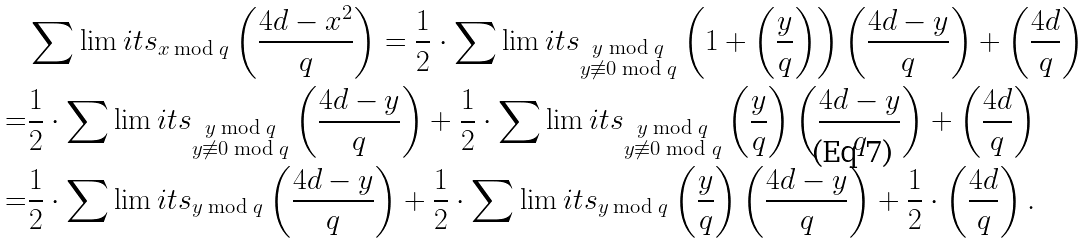Convert formula to latex. <formula><loc_0><loc_0><loc_500><loc_500>& \sum \lim i t s _ { x \bmod { q } } \left ( \frac { 4 d - x ^ { 2 } } { q } \right ) = \frac { 1 } { 2 } \cdot \sum \lim i t s _ { \substack { y \bmod { q } \\ y \not \equiv 0 \bmod { q } } } \left ( 1 + \left ( \frac { y } { q } \right ) \right ) \left ( \frac { 4 d - y } { q } \right ) + \left ( \frac { 4 d } { q } \right ) \\ = & \frac { 1 } { 2 } \cdot \sum \lim i t s _ { \substack { y \bmod { q } \\ y \not \equiv 0 \bmod { q } } } \left ( \frac { 4 d - y } { q } \right ) + \frac { 1 } { 2 } \cdot \sum \lim i t s _ { \substack { y \bmod { q } \\ y \not \equiv 0 \bmod { q } } } \left ( \frac { y } { q } \right ) \left ( \frac { 4 d - y } { q } \right ) + \left ( \frac { 4 d } { q } \right ) \\ = & \frac { 1 } { 2 } \cdot \sum \lim i t s _ { \substack { y \bmod { q } } } \left ( \frac { 4 d - y } { q } \right ) + \frac { 1 } { 2 } \cdot \sum \lim i t s _ { \substack { y \bmod { q } } } \left ( \frac { y } { q } \right ) \left ( \frac { 4 d - y } { q } \right ) + \frac { 1 } { 2 } \cdot \left ( \frac { 4 d } { q } \right ) .</formula> 